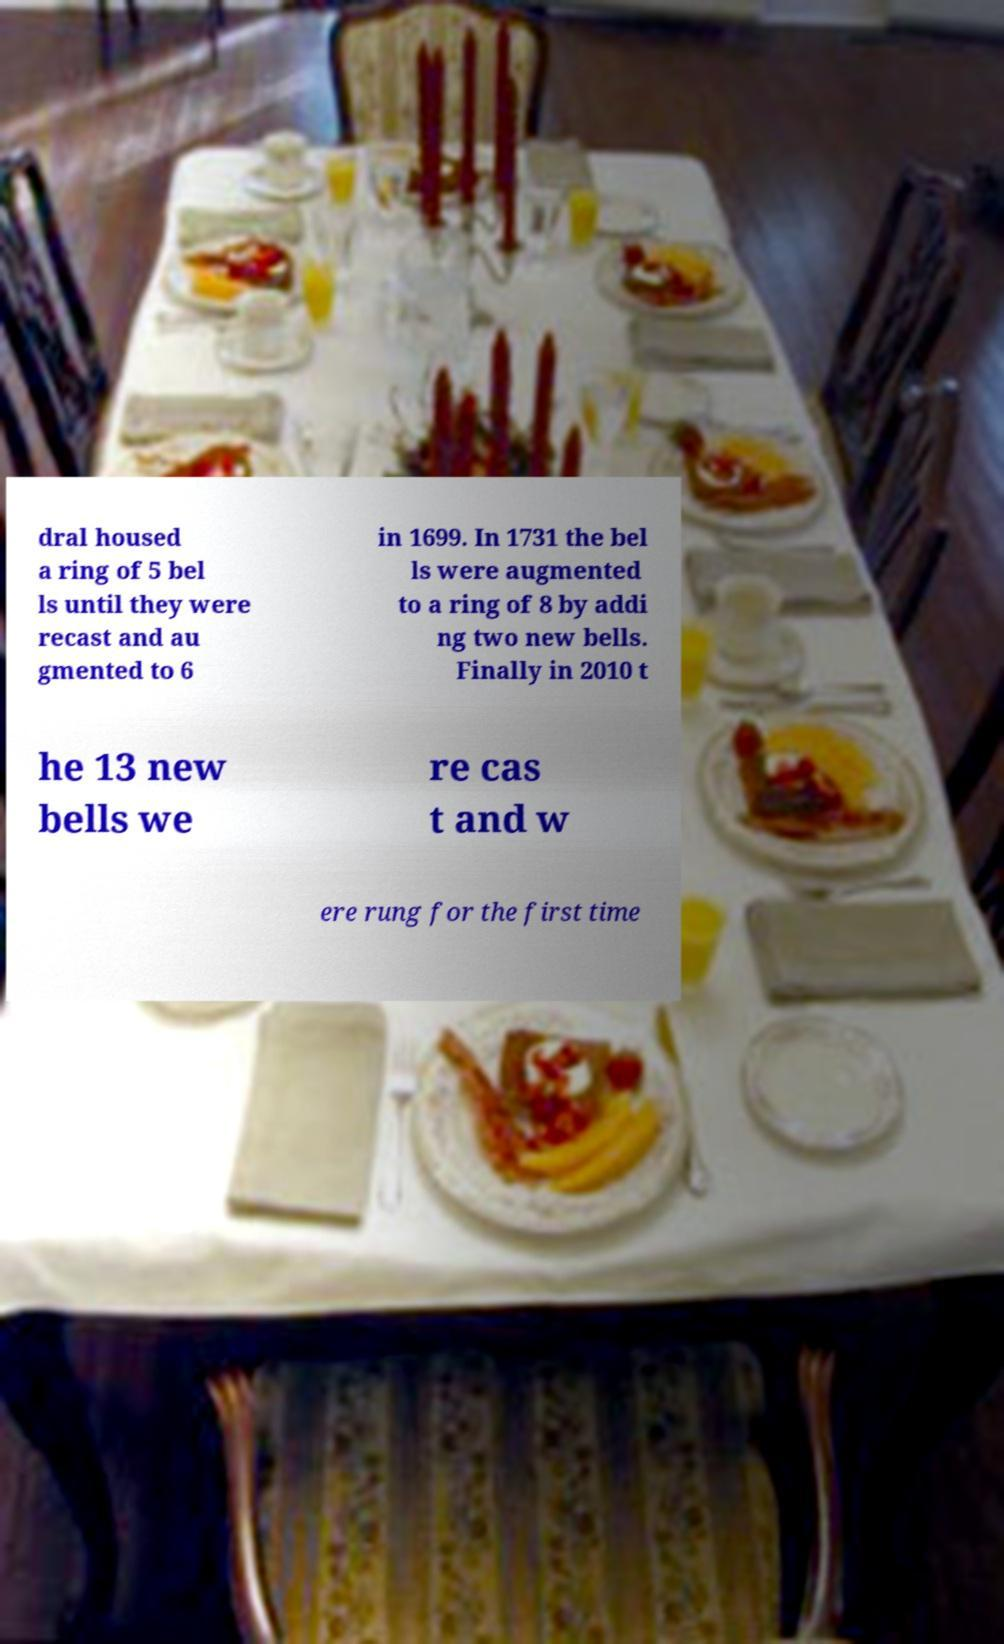Could you extract and type out the text from this image? dral housed a ring of 5 bel ls until they were recast and au gmented to 6 in 1699. In 1731 the bel ls were augmented to a ring of 8 by addi ng two new bells. Finally in 2010 t he 13 new bells we re cas t and w ere rung for the first time 